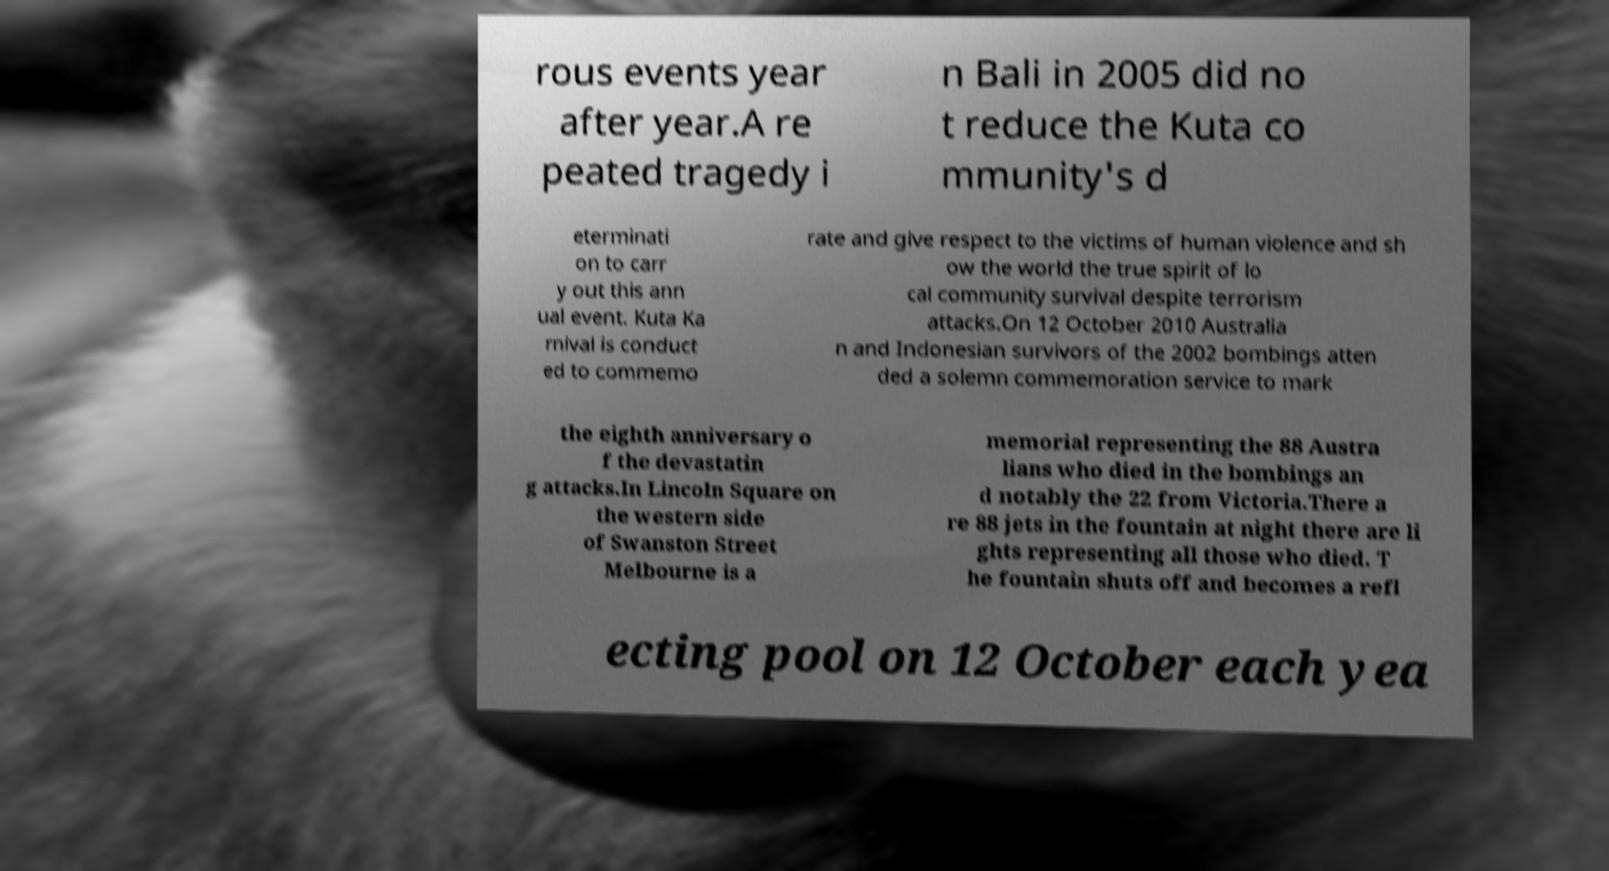Please read and relay the text visible in this image. What does it say? rous events year after year.A re peated tragedy i n Bali in 2005 did no t reduce the Kuta co mmunity's d eterminati on to carr y out this ann ual event. Kuta Ka rnival is conduct ed to commemo rate and give respect to the victims of human violence and sh ow the world the true spirit of lo cal community survival despite terrorism attacks.On 12 October 2010 Australia n and Indonesian survivors of the 2002 bombings atten ded a solemn commemoration service to mark the eighth anniversary o f the devastatin g attacks.In Lincoln Square on the western side of Swanston Street Melbourne is a memorial representing the 88 Austra lians who died in the bombings an d notably the 22 from Victoria.There a re 88 jets in the fountain at night there are li ghts representing all those who died. T he fountain shuts off and becomes a refl ecting pool on 12 October each yea 